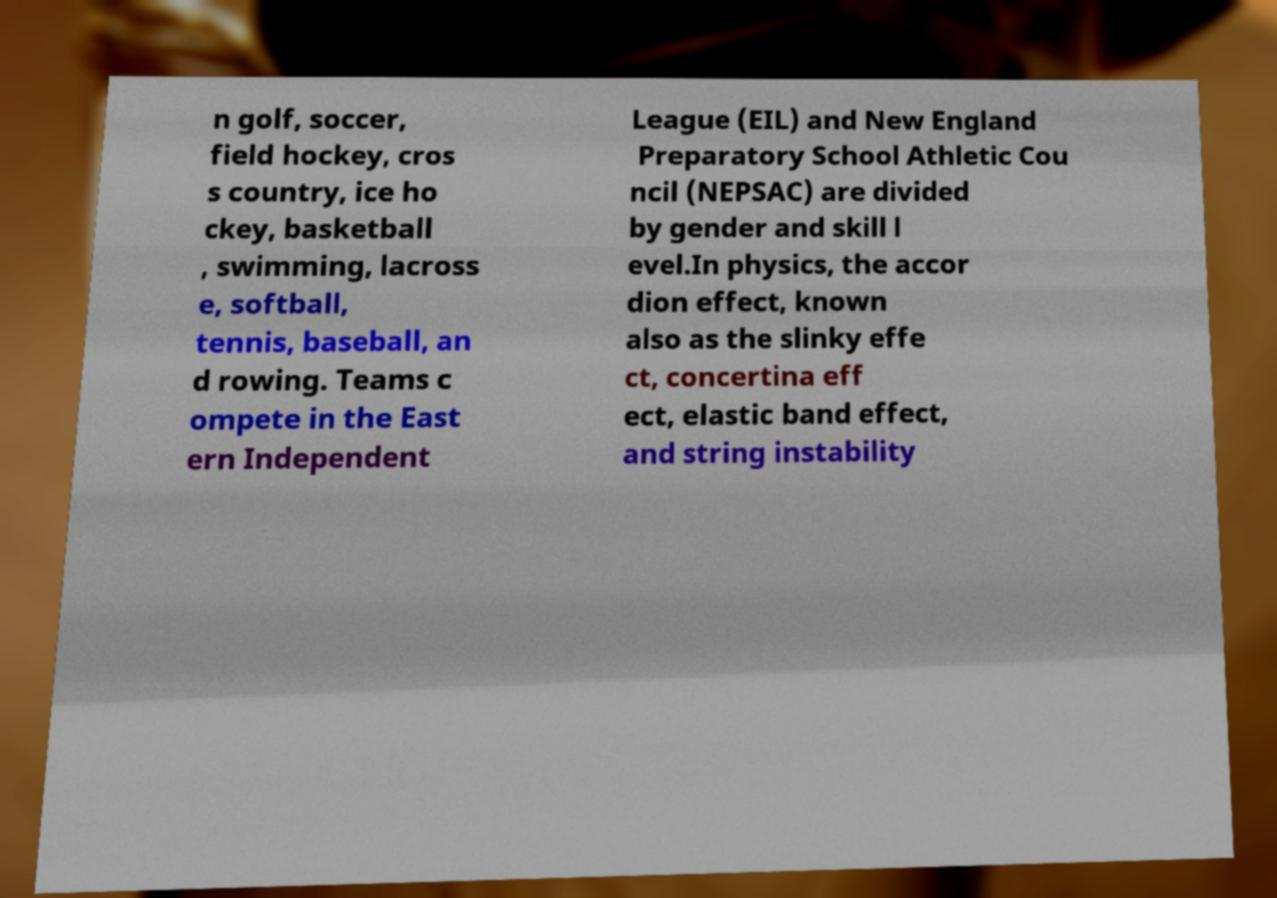I need the written content from this picture converted into text. Can you do that? n golf, soccer, field hockey, cros s country, ice ho ckey, basketball , swimming, lacross e, softball, tennis, baseball, an d rowing. Teams c ompete in the East ern Independent League (EIL) and New England Preparatory School Athletic Cou ncil (NEPSAC) are divided by gender and skill l evel.In physics, the accor dion effect, known also as the slinky effe ct, concertina eff ect, elastic band effect, and string instability 